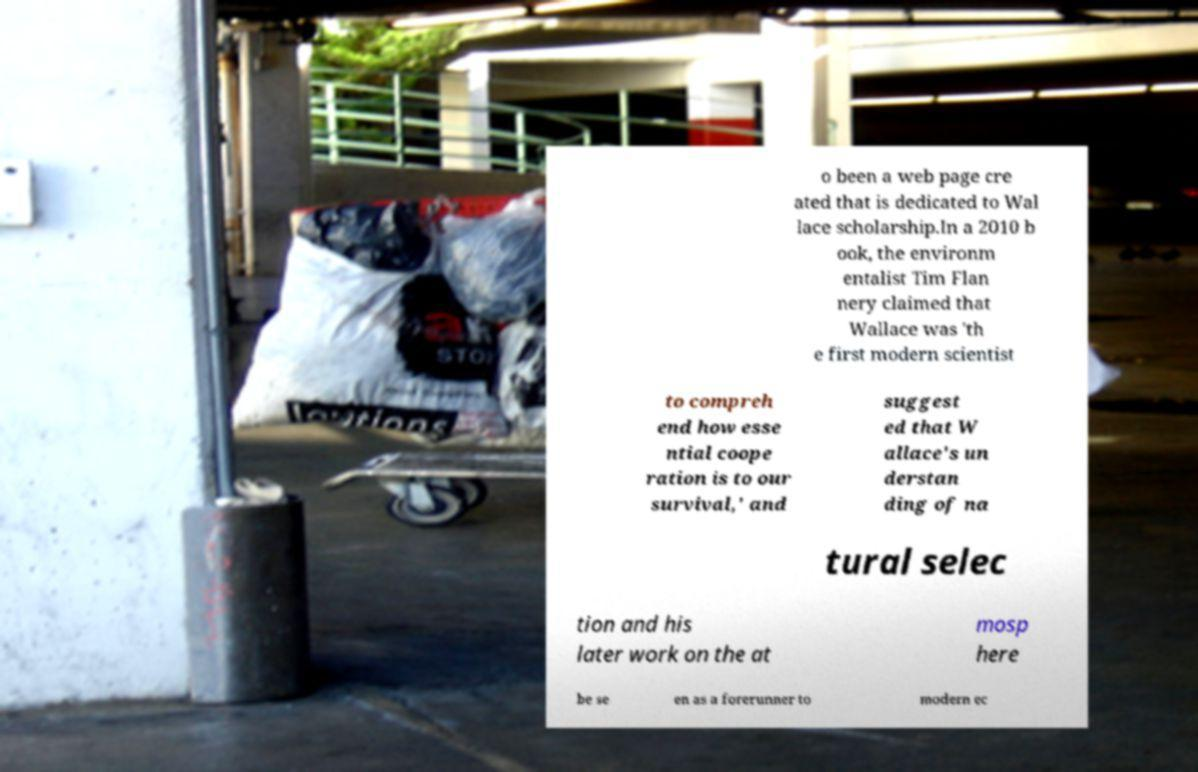Please read and relay the text visible in this image. What does it say? o been a web page cre ated that is dedicated to Wal lace scholarship.In a 2010 b ook, the environm entalist Tim Flan nery claimed that Wallace was 'th e first modern scientist to compreh end how esse ntial coope ration is to our survival,' and suggest ed that W allace's un derstan ding of na tural selec tion and his later work on the at mosp here be se en as a forerunner to modern ec 